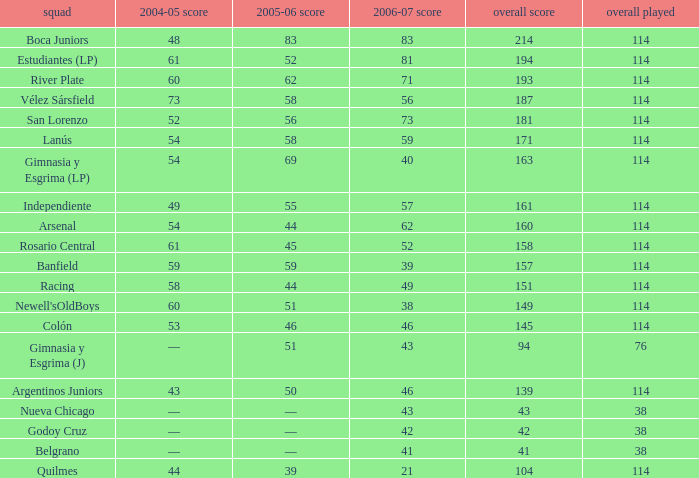What is the average total pld with 45 points in 2005-06, and more than 52 points in 2006-07? None. 